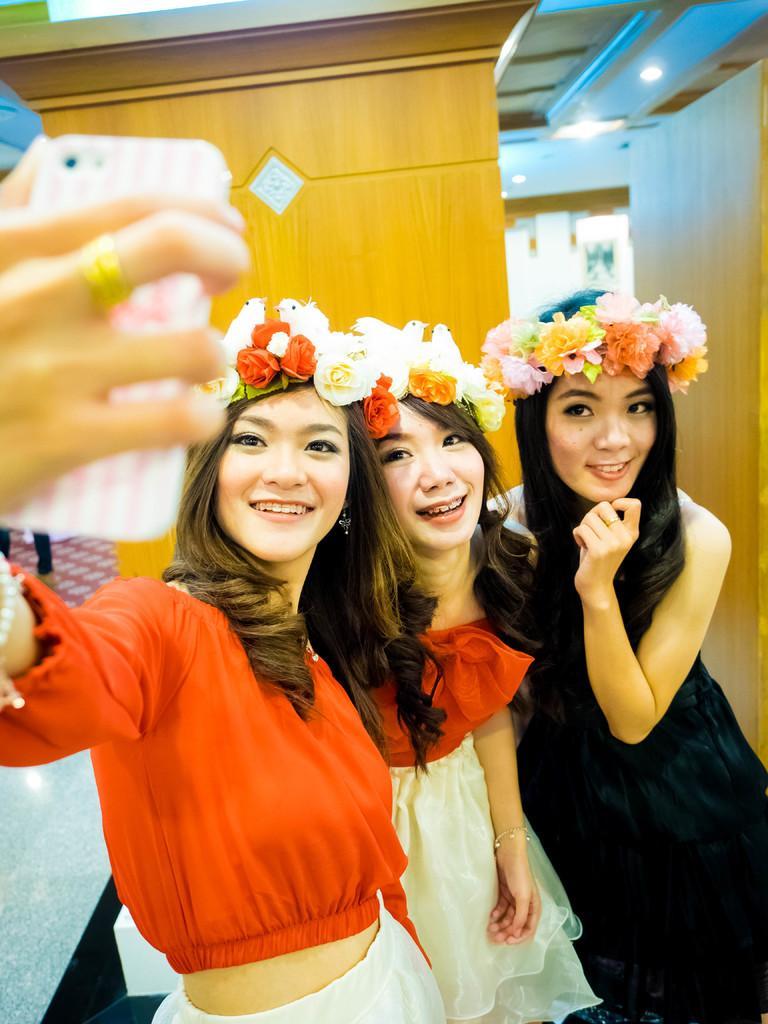In one or two sentences, can you explain what this image depicts? In this image we can see three women standing. In that a woman is holding a mobile phone. On the backside we can see the walls and some ceiling lights to a roof. On the left side we can see the legs of a person. 